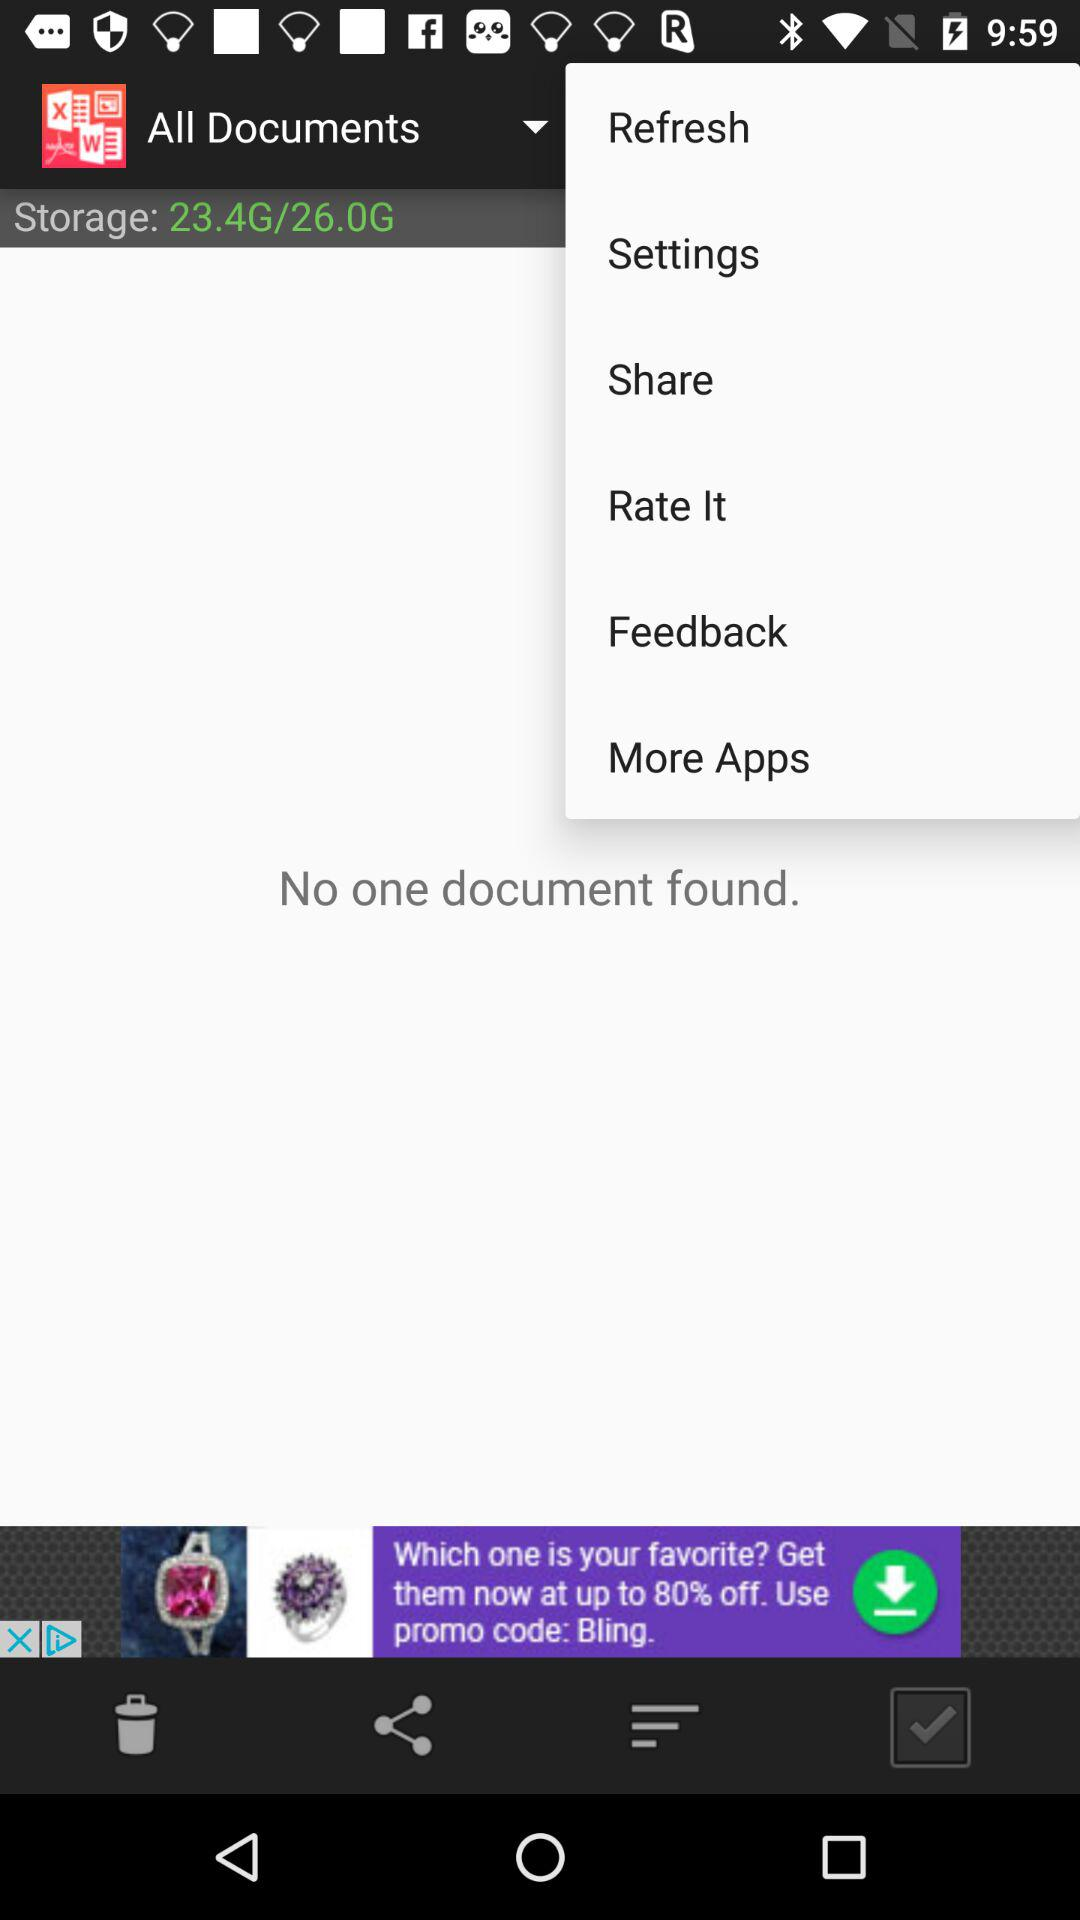How many documents were found? There were no documents found. 